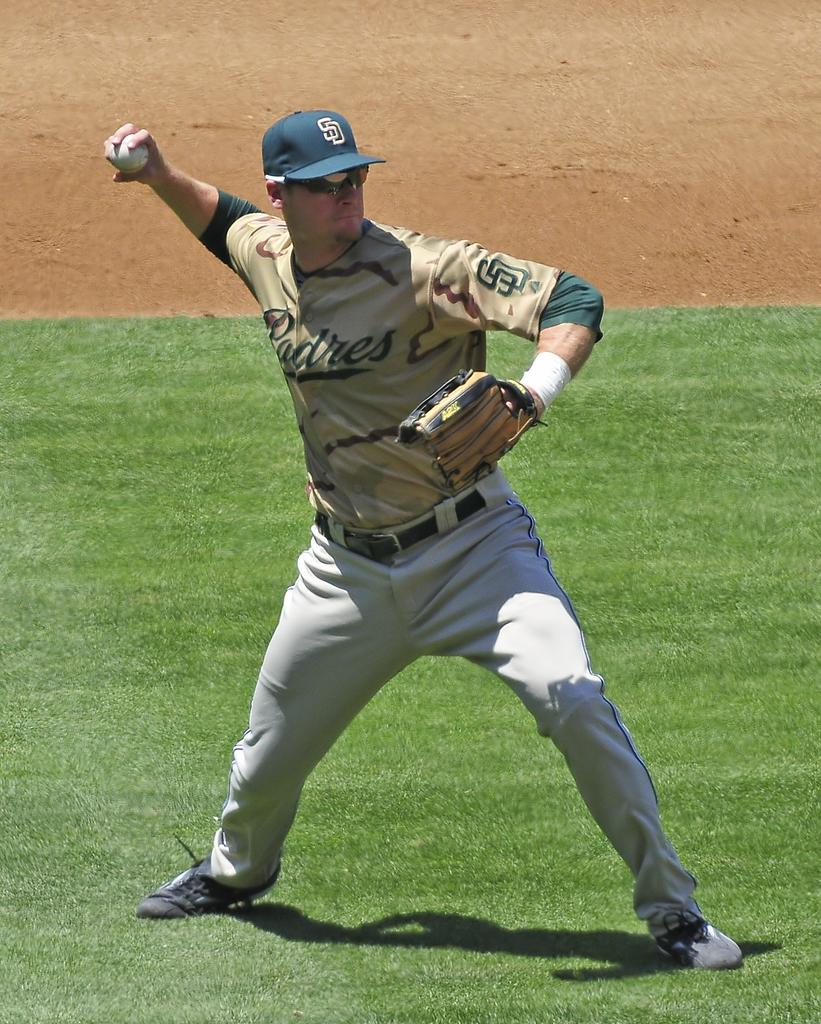<image>
Relay a brief, clear account of the picture shown. A baseball player in a Padres uniform throws the ball. 